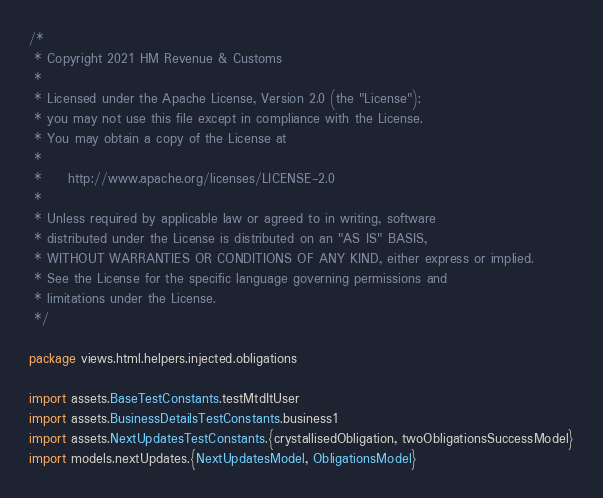<code> <loc_0><loc_0><loc_500><loc_500><_Scala_>/*
 * Copyright 2021 HM Revenue & Customs
 *
 * Licensed under the Apache License, Version 2.0 (the "License");
 * you may not use this file except in compliance with the License.
 * You may obtain a copy of the License at
 *
 *     http://www.apache.org/licenses/LICENSE-2.0
 *
 * Unless required by applicable law or agreed to in writing, software
 * distributed under the License is distributed on an "AS IS" BASIS,
 * WITHOUT WARRANTIES OR CONDITIONS OF ANY KIND, either express or implied.
 * See the License for the specific language governing permissions and
 * limitations under the License.
 */

package views.html.helpers.injected.obligations

import assets.BaseTestConstants.testMtdItUser
import assets.BusinessDetailsTestConstants.business1
import assets.NextUpdatesTestConstants.{crystallisedObligation, twoObligationsSuccessModel}
import models.nextUpdates.{NextUpdatesModel, ObligationsModel}</code> 